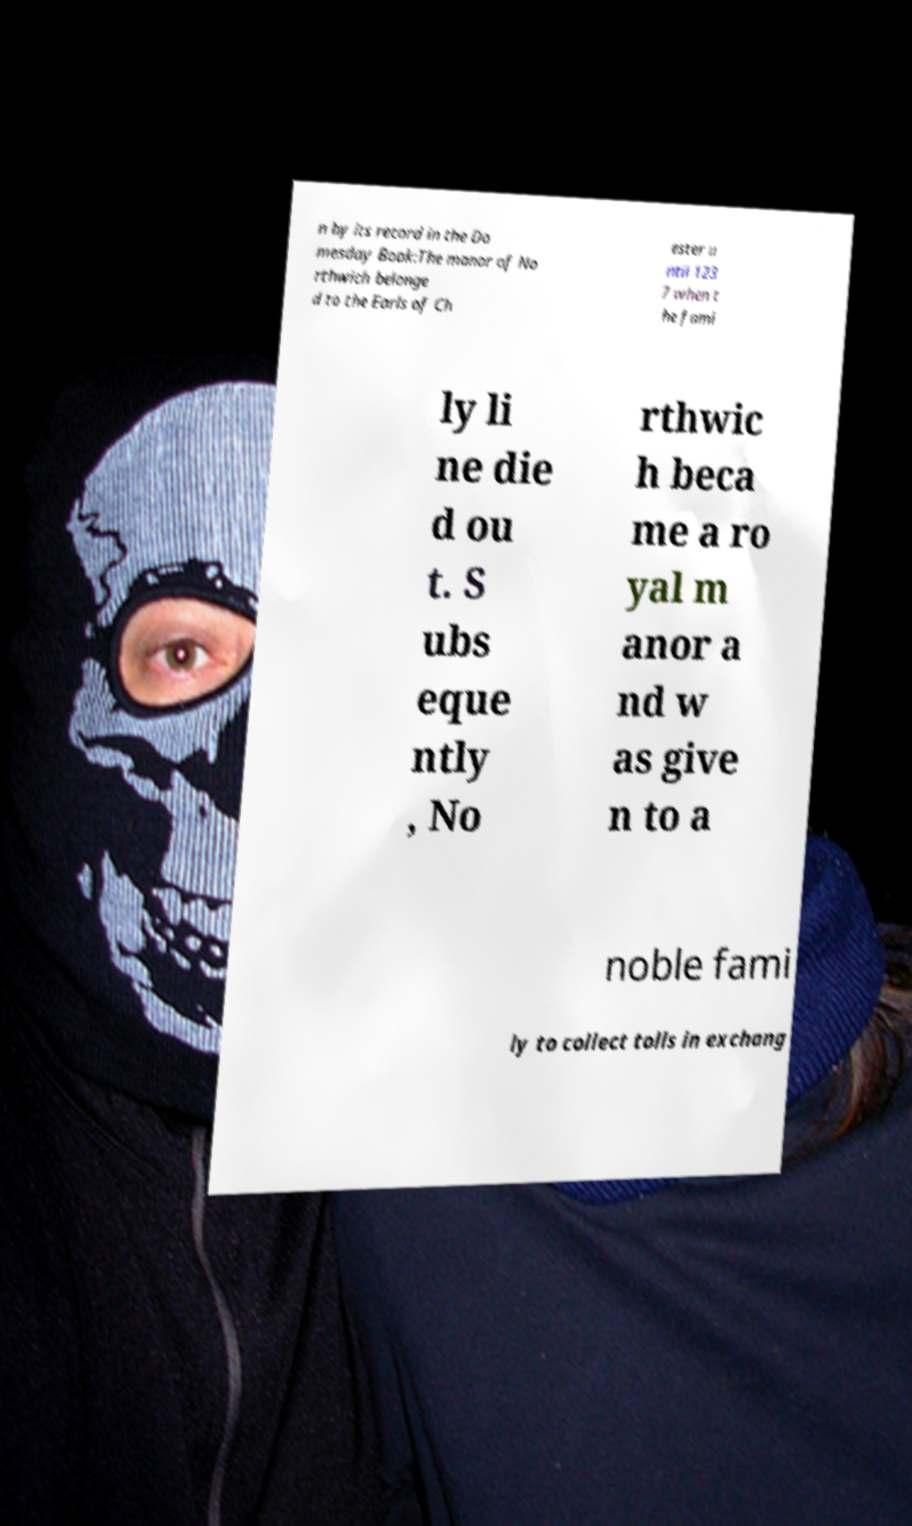Please read and relay the text visible in this image. What does it say? n by its record in the Do mesday Book:The manor of No rthwich belonge d to the Earls of Ch ester u ntil 123 7 when t he fami ly li ne die d ou t. S ubs eque ntly , No rthwic h beca me a ro yal m anor a nd w as give n to a noble fami ly to collect tolls in exchang 